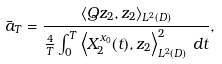<formula> <loc_0><loc_0><loc_500><loc_500>\bar { a } _ { T } = \frac { \left \langle Q z _ { 2 } , z _ { 2 } \right \rangle _ { L ^ { 2 } ( D ) } } { \frac { 4 } { T } \int _ { 0 } ^ { T } \left \langle X _ { 2 } ^ { x _ { 0 } } ( t ) , z _ { 2 } \right \rangle _ { L ^ { 2 } ( D ) } ^ { 2 } \, d t } ,</formula> 